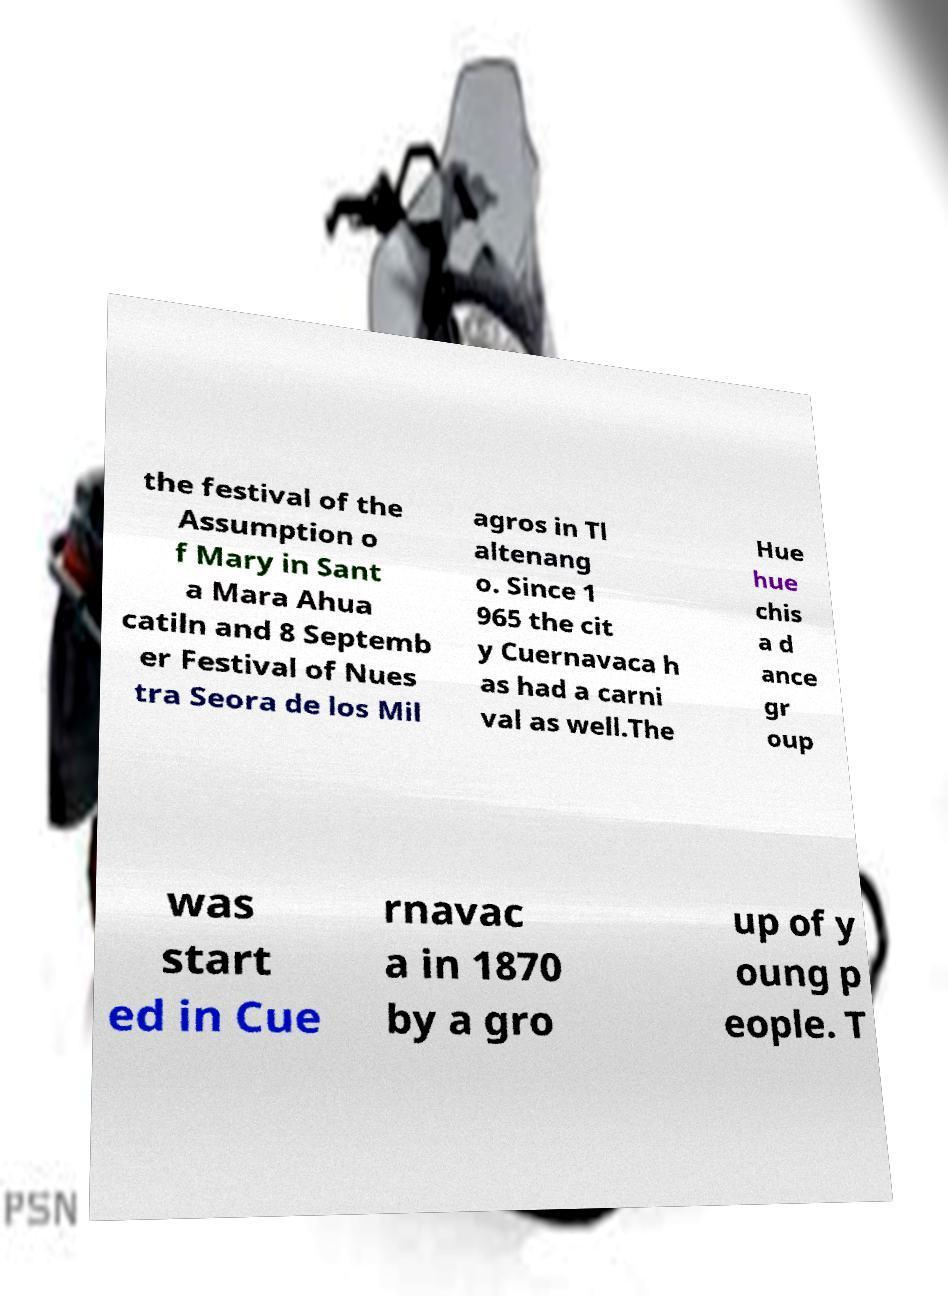Could you assist in decoding the text presented in this image and type it out clearly? the festival of the Assumption o f Mary in Sant a Mara Ahua catiln and 8 Septemb er Festival of Nues tra Seora de los Mil agros in Tl altenang o. Since 1 965 the cit y Cuernavaca h as had a carni val as well.The Hue hue chis a d ance gr oup was start ed in Cue rnavac a in 1870 by a gro up of y oung p eople. T 